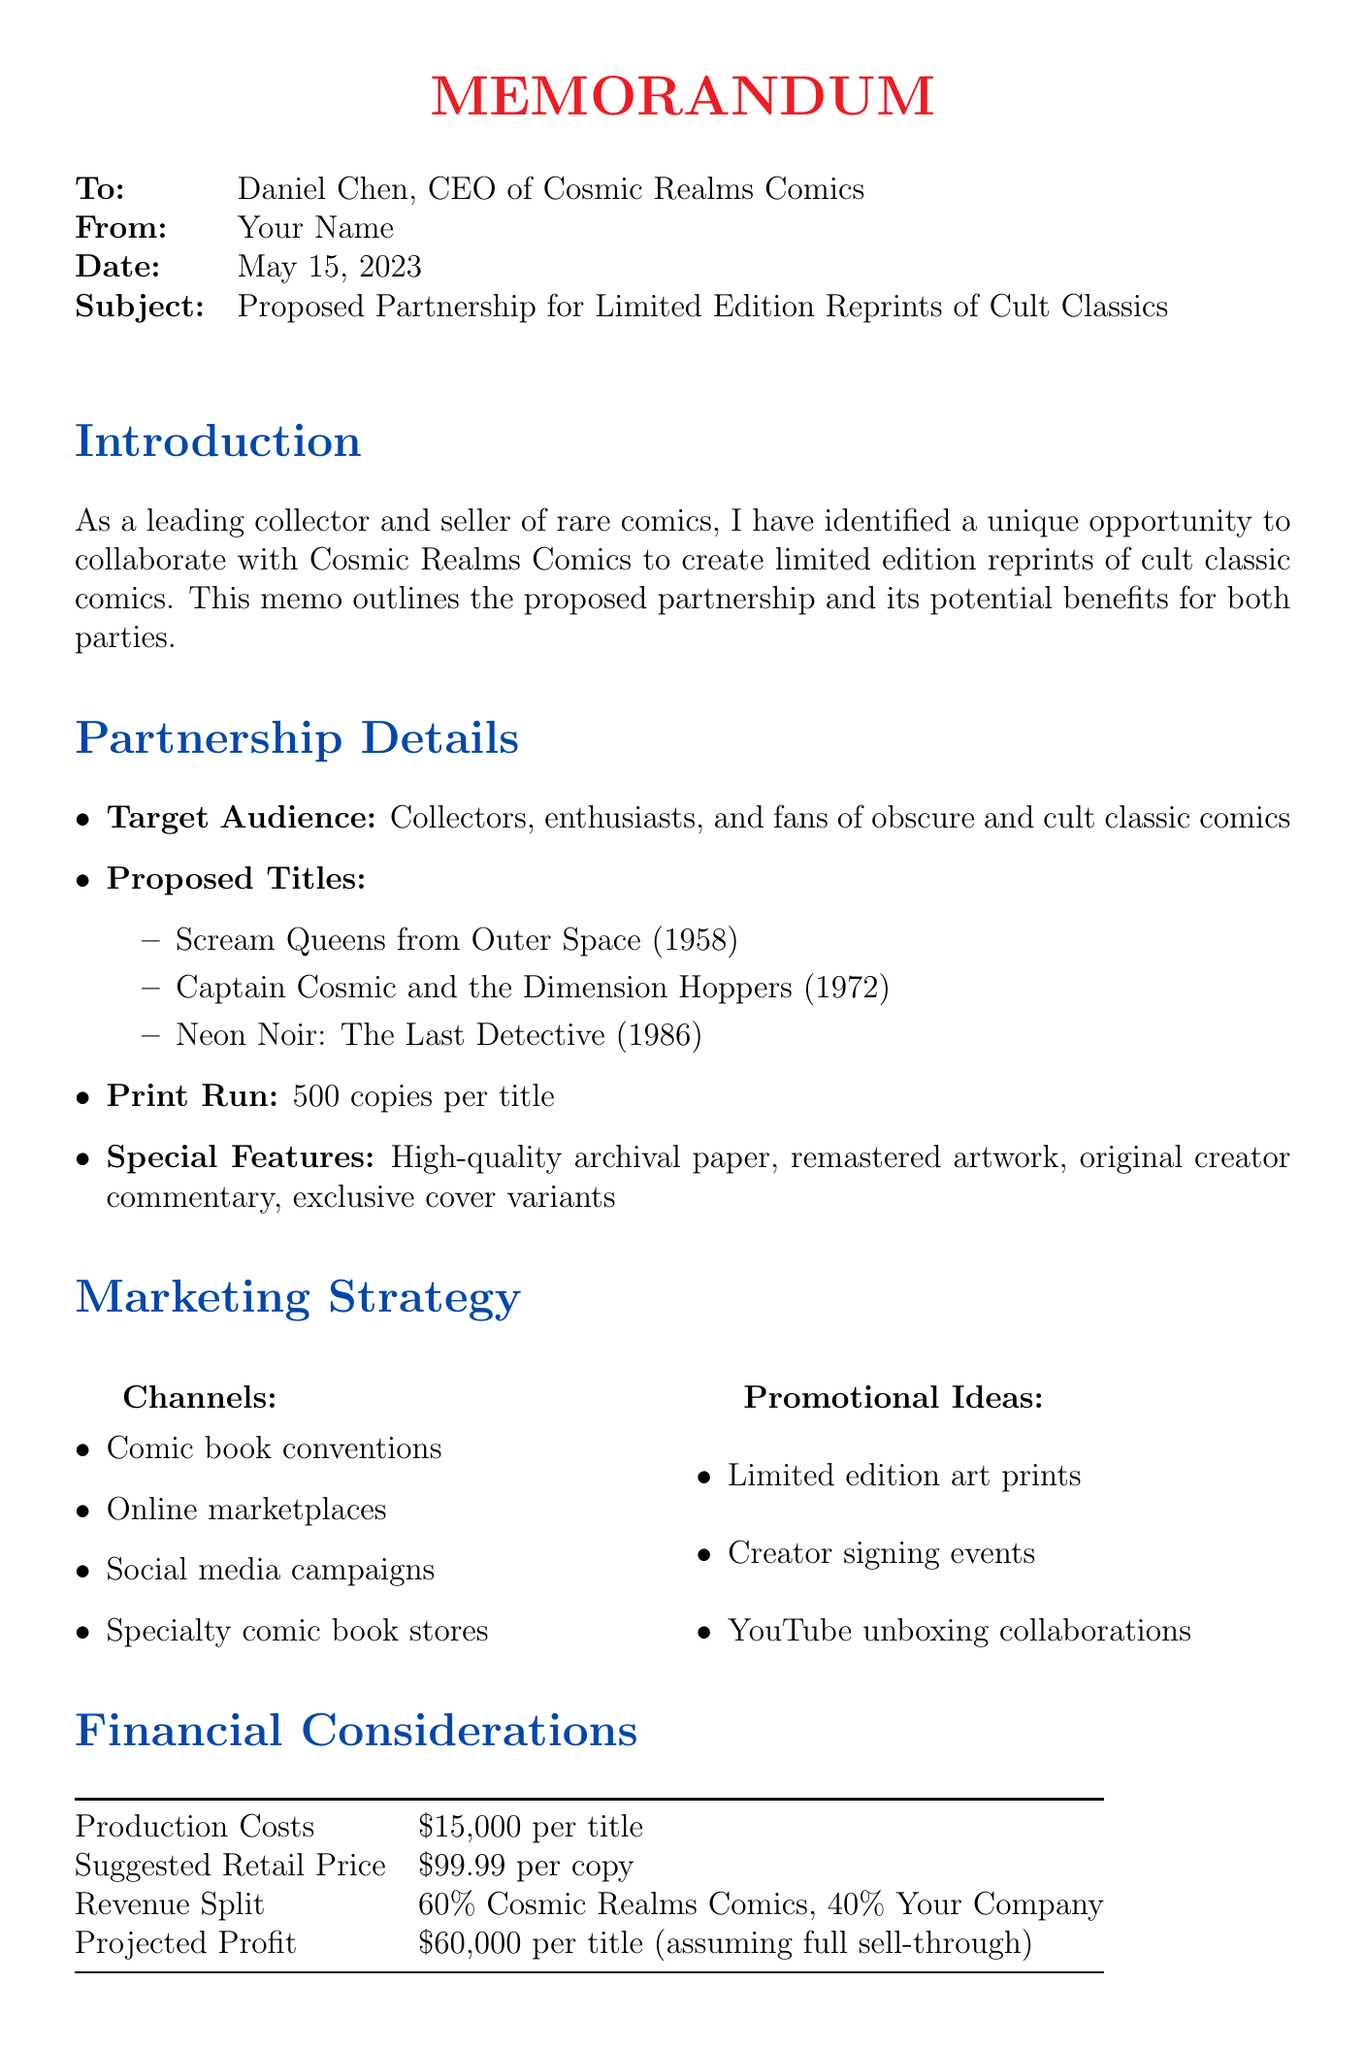What is the target audience for the proposed partnership? The target audience is mentioned in the partnership details, specifically focusing on collectors, enthusiasts, and fans of obscure and cult classic comics.
Answer: Collectors, enthusiasts, and fans of obscure and cult classic comics How many copies will be printed per title? The document states the print run for each title in the partnership details section.
Answer: 500 copies per title What is the projected profit per title? The projected profit is provided in the financial considerations section, indicating the expected revenue after costs.
Answer: $60,000 per title What are the proposed titles for reprints? The proposed titles are listed under the partnership details, providing a selection of cult classic comics.
Answer: Scream Queens from Outer Space (1958), Captain Cosmic and the Dimension Hoppers (1972), Neon Noir: The Last Detective (1986) What is the suggested retail price per copy? The suggested retail price is noted in the financial considerations section, indicating how much each copy will retail for.
Answer: $99.99 per copy What is the duration of the title selection and rights acquisition phase? The timeline outlines the duration of each phase and specifically indicates how long this particular phase will take.
Answer: 2 months What is one potential challenge mentioned in the memo? The potential challenges are listed, detailing issues that could arise from the partnership and the reprints.
Answer: Securing rights from original creators or their estates What marketing channels are mentioned for promoting the reprints? The marketing strategy section outlines the different channels that will be utilized to promote the comics.
Answer: Comic book conventions, online marketplaces, social media campaigns, specialty comic book stores What happens after the conclusion of the partnership? The next steps are stated in the conclusion, indicating what should occur if the CEO is interested in pursuing the partnership.
Answer: Schedule a meeting to discuss the details further and begin the title selection process 